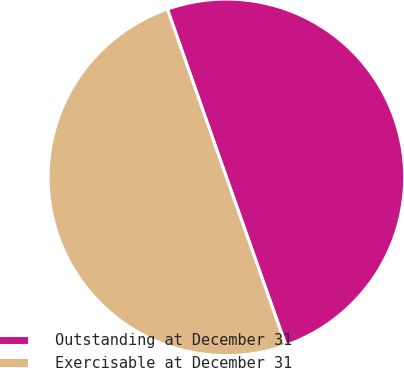Convert chart. <chart><loc_0><loc_0><loc_500><loc_500><pie_chart><fcel>Outstanding at December 31<fcel>Exercisable at December 31<nl><fcel>49.96%<fcel>50.04%<nl></chart> 